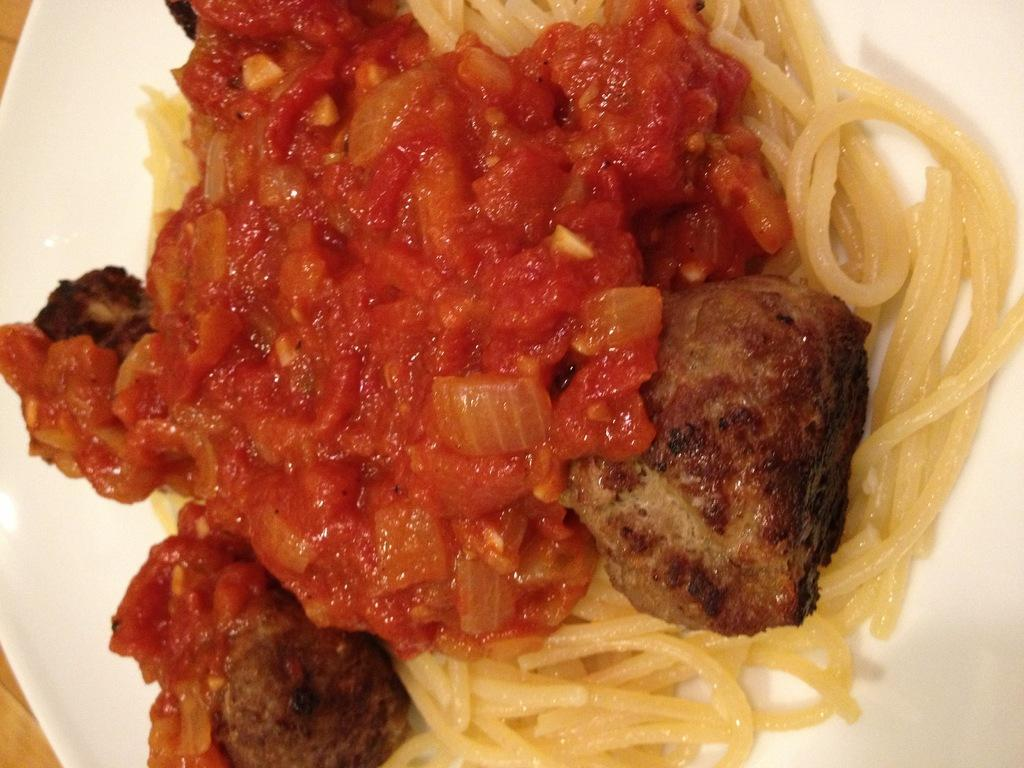What piece of furniture is present in the image? There is a table in the image. What is placed on the table? There is a plate on the table. What is on the plate? The plate contains food. What type of army is depicted on the plate in the image? There is no army depicted on the plate in the image; it contains food. 